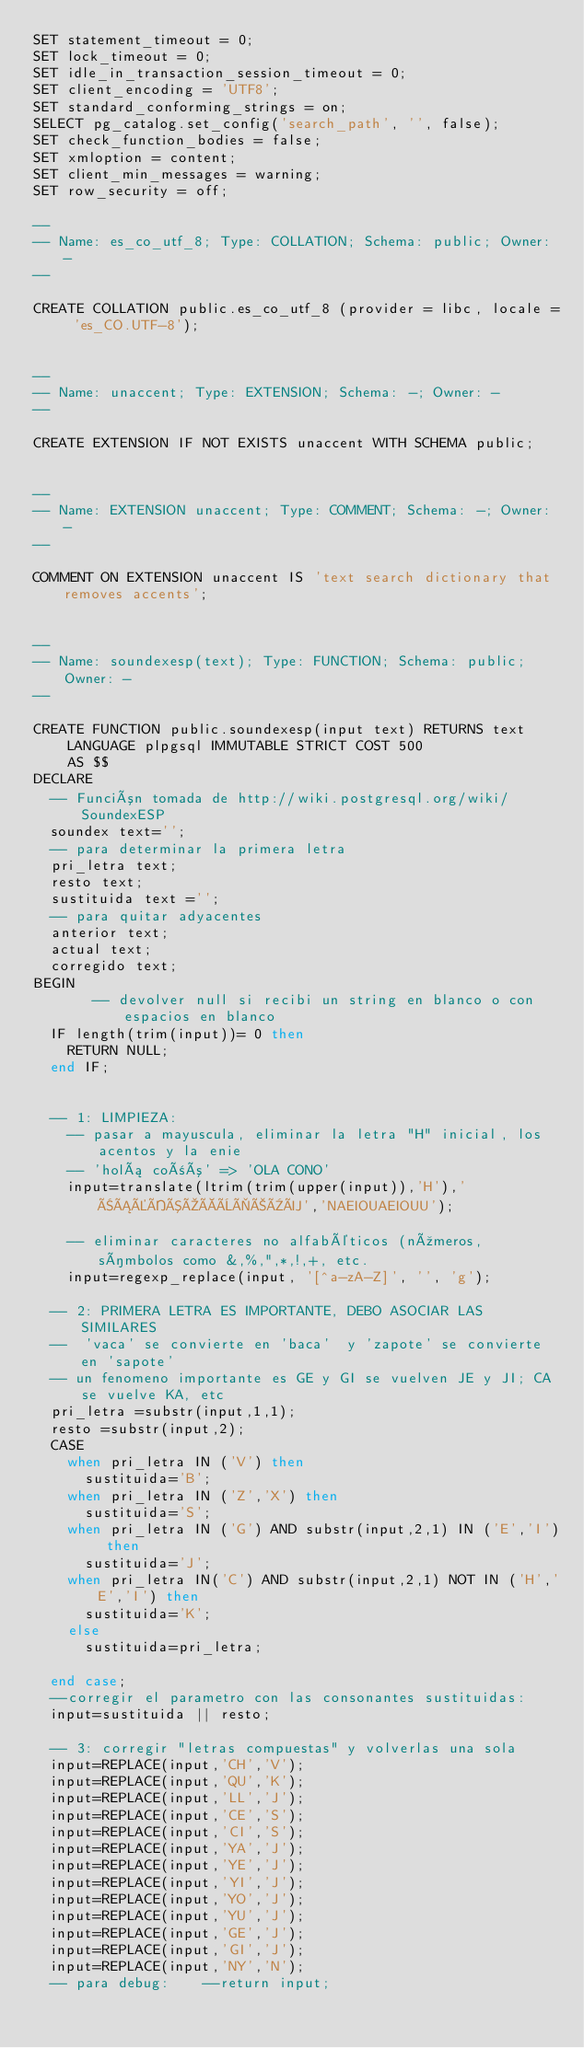<code> <loc_0><loc_0><loc_500><loc_500><_SQL_>SET statement_timeout = 0;
SET lock_timeout = 0;
SET idle_in_transaction_session_timeout = 0;
SET client_encoding = 'UTF8';
SET standard_conforming_strings = on;
SELECT pg_catalog.set_config('search_path', '', false);
SET check_function_bodies = false;
SET xmloption = content;
SET client_min_messages = warning;
SET row_security = off;

--
-- Name: es_co_utf_8; Type: COLLATION; Schema: public; Owner: -
--

CREATE COLLATION public.es_co_utf_8 (provider = libc, locale = 'es_CO.UTF-8');


--
-- Name: unaccent; Type: EXTENSION; Schema: -; Owner: -
--

CREATE EXTENSION IF NOT EXISTS unaccent WITH SCHEMA public;


--
-- Name: EXTENSION unaccent; Type: COMMENT; Schema: -; Owner: -
--

COMMENT ON EXTENSION unaccent IS 'text search dictionary that removes accents';


--
-- Name: soundexesp(text); Type: FUNCTION; Schema: public; Owner: -
--

CREATE FUNCTION public.soundexesp(input text) RETURNS text
    LANGUAGE plpgsql IMMUTABLE STRICT COST 500
    AS $$
DECLARE
	-- Función tomada de http://wiki.postgresql.org/wiki/SoundexESP
	soundex text='';	
	-- para determinar la primera letra
	pri_letra text;
	resto text;
	sustituida text ='';
	-- para quitar adyacentes
	anterior text;
	actual text;
	corregido text;
BEGIN
       -- devolver null si recibi un string en blanco o con espacios en blanco
	IF length(trim(input))= 0 then
		RETURN NULL;
	end IF;
 
 
	-- 1: LIMPIEZA:
		-- pasar a mayuscula, eliminar la letra "H" inicial, los acentos y la enie
		-- 'holá coñó' => 'OLA CONO'
		input=translate(ltrim(trim(upper(input)),'H'),'ÑÁÉÍÓÚÀÈÌÒÙÜ','NAEIOUAEIOUU');
 
		-- eliminar caracteres no alfabéticos (números, símbolos como &,%,",*,!,+, etc.
		input=regexp_replace(input, '[^a-zA-Z]', '', 'g');
 
	-- 2: PRIMERA LETRA ES IMPORTANTE, DEBO ASOCIAR LAS SIMILARES
	--  'vaca' se convierte en 'baca'  y 'zapote' se convierte en 'sapote'
	-- un fenomeno importante es GE y GI se vuelven JE y JI; CA se vuelve KA, etc
	pri_letra =substr(input,1,1);
	resto =substr(input,2);
	CASE 
		when pri_letra IN ('V') then
			sustituida='B';
		when pri_letra IN ('Z','X') then
			sustituida='S';
		when pri_letra IN ('G') AND substr(input,2,1) IN ('E','I') then
			sustituida='J';
		when pri_letra IN('C') AND substr(input,2,1) NOT IN ('H','E','I') then
			sustituida='K';
		else
			sustituida=pri_letra;
 
	end case;
	--corregir el parametro con las consonantes sustituidas:
	input=sustituida || resto;		
 
	-- 3: corregir "letras compuestas" y volverlas una sola
	input=REPLACE(input,'CH','V');
	input=REPLACE(input,'QU','K');
	input=REPLACE(input,'LL','J');
	input=REPLACE(input,'CE','S');
	input=REPLACE(input,'CI','S');
	input=REPLACE(input,'YA','J');
	input=REPLACE(input,'YE','J');
	input=REPLACE(input,'YI','J');
	input=REPLACE(input,'YO','J');
	input=REPLACE(input,'YU','J');
	input=REPLACE(input,'GE','J');
	input=REPLACE(input,'GI','J');
	input=REPLACE(input,'NY','N');
	-- para debug:    --return input;
 </code> 